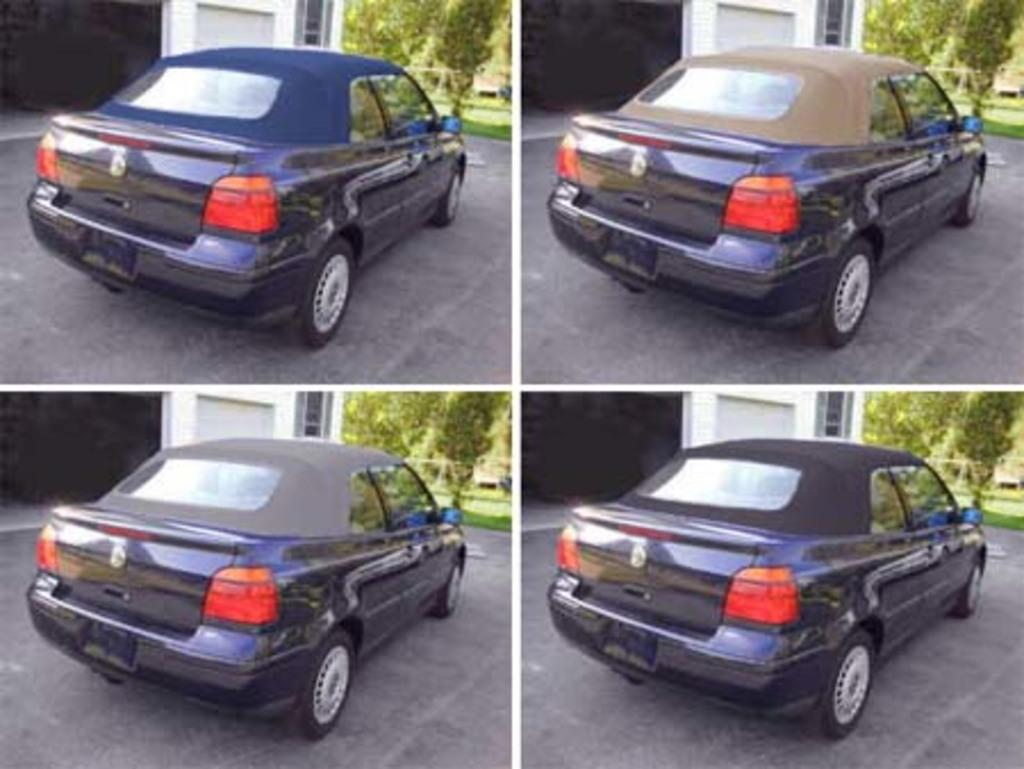What type of artwork is the image? The image is a collage. What can be seen in the collage? There are cars in the image. What is in front of the cars? Trees are present in front of the cars. What is beside the cars? There are walls beside the cars. What is at the bottom of the image? A road is visible at the bottom of the image. What time of day is depicted in the image, and how many hours does it represent? The image does not depict a specific time of day, nor does it represent a specific number of hours. 